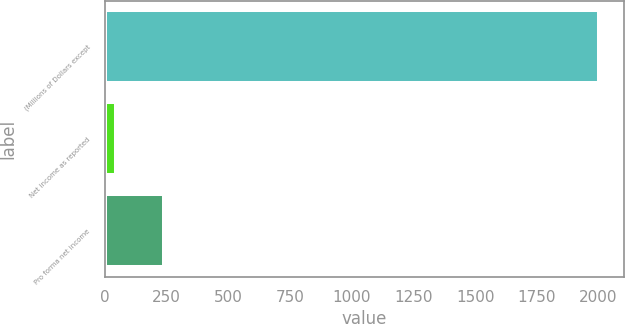<chart> <loc_0><loc_0><loc_500><loc_500><bar_chart><fcel>(Millions of Dollars except<fcel>Net income as reported<fcel>Pro forma net income<nl><fcel>2002<fcel>45<fcel>240.7<nl></chart> 